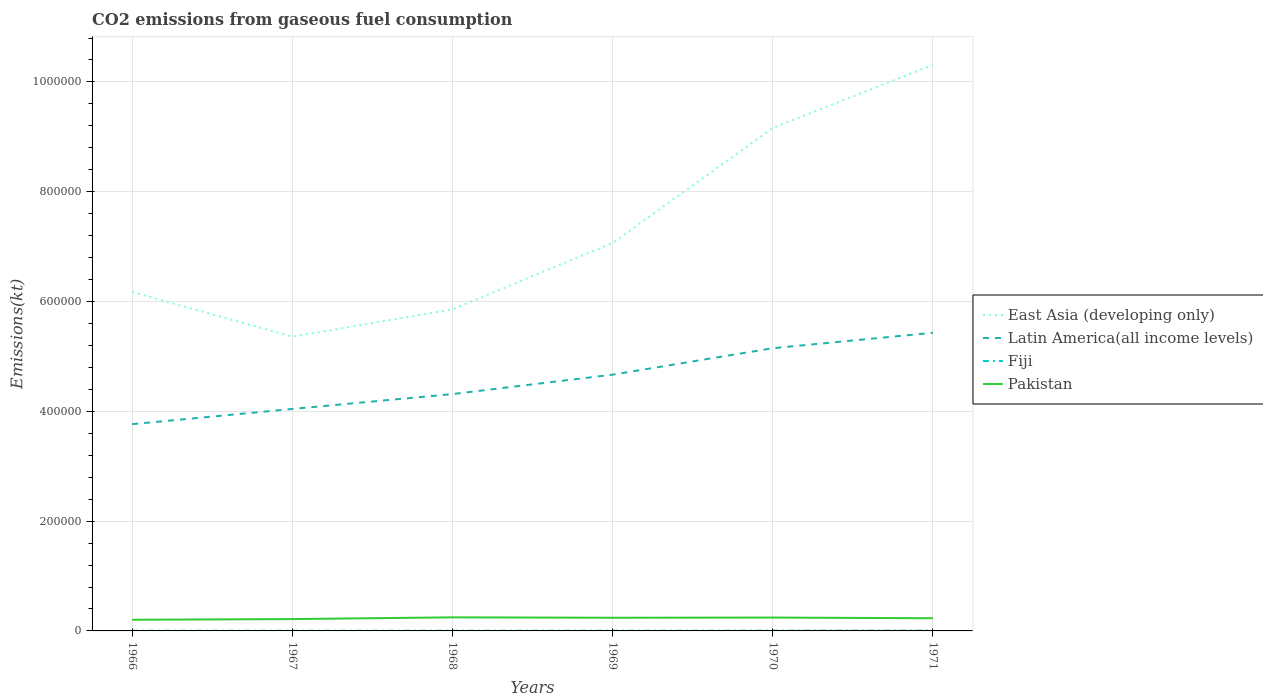Is the number of lines equal to the number of legend labels?
Your response must be concise. Yes. Across all years, what is the maximum amount of CO2 emitted in Latin America(all income levels)?
Provide a succinct answer. 3.77e+05. In which year was the amount of CO2 emitted in East Asia (developing only) maximum?
Offer a very short reply. 1967. What is the total amount of CO2 emitted in Latin America(all income levels) in the graph?
Your response must be concise. -7.63e+04. What is the difference between the highest and the second highest amount of CO2 emitted in East Asia (developing only)?
Your response must be concise. 4.95e+05. How many lines are there?
Make the answer very short. 4. What is the difference between two consecutive major ticks on the Y-axis?
Your answer should be compact. 2.00e+05. Does the graph contain any zero values?
Make the answer very short. No. Where does the legend appear in the graph?
Provide a succinct answer. Center right. How many legend labels are there?
Make the answer very short. 4. What is the title of the graph?
Make the answer very short. CO2 emissions from gaseous fuel consumption. Does "Vanuatu" appear as one of the legend labels in the graph?
Provide a short and direct response. No. What is the label or title of the X-axis?
Give a very brief answer. Years. What is the label or title of the Y-axis?
Provide a short and direct response. Emissions(kt). What is the Emissions(kt) of East Asia (developing only) in 1966?
Your answer should be very brief. 6.17e+05. What is the Emissions(kt) in Latin America(all income levels) in 1966?
Ensure brevity in your answer.  3.77e+05. What is the Emissions(kt) of Fiji in 1966?
Your answer should be compact. 322.7. What is the Emissions(kt) in Pakistan in 1966?
Your response must be concise. 2.03e+04. What is the Emissions(kt) in East Asia (developing only) in 1967?
Provide a short and direct response. 5.36e+05. What is the Emissions(kt) of Latin America(all income levels) in 1967?
Make the answer very short. 4.04e+05. What is the Emissions(kt) of Fiji in 1967?
Provide a short and direct response. 355.7. What is the Emissions(kt) in Pakistan in 1967?
Make the answer very short. 2.16e+04. What is the Emissions(kt) of East Asia (developing only) in 1968?
Make the answer very short. 5.86e+05. What is the Emissions(kt) in Latin America(all income levels) in 1968?
Your answer should be very brief. 4.31e+05. What is the Emissions(kt) in Fiji in 1968?
Your response must be concise. 396.04. What is the Emissions(kt) of Pakistan in 1968?
Give a very brief answer. 2.47e+04. What is the Emissions(kt) of East Asia (developing only) in 1969?
Your answer should be compact. 7.07e+05. What is the Emissions(kt) in Latin America(all income levels) in 1969?
Offer a very short reply. 4.67e+05. What is the Emissions(kt) of Fiji in 1969?
Make the answer very short. 432.71. What is the Emissions(kt) of Pakistan in 1969?
Your response must be concise. 2.40e+04. What is the Emissions(kt) of East Asia (developing only) in 1970?
Keep it short and to the point. 9.16e+05. What is the Emissions(kt) in Latin America(all income levels) in 1970?
Provide a short and direct response. 5.15e+05. What is the Emissions(kt) of Fiji in 1970?
Offer a terse response. 520.71. What is the Emissions(kt) of Pakistan in 1970?
Give a very brief answer. 2.43e+04. What is the Emissions(kt) of East Asia (developing only) in 1971?
Keep it short and to the point. 1.03e+06. What is the Emissions(kt) of Latin America(all income levels) in 1971?
Offer a terse response. 5.43e+05. What is the Emissions(kt) of Fiji in 1971?
Keep it short and to the point. 550.05. What is the Emissions(kt) of Pakistan in 1971?
Your answer should be compact. 2.31e+04. Across all years, what is the maximum Emissions(kt) in East Asia (developing only)?
Give a very brief answer. 1.03e+06. Across all years, what is the maximum Emissions(kt) of Latin America(all income levels)?
Keep it short and to the point. 5.43e+05. Across all years, what is the maximum Emissions(kt) of Fiji?
Your answer should be compact. 550.05. Across all years, what is the maximum Emissions(kt) of Pakistan?
Your response must be concise. 2.47e+04. Across all years, what is the minimum Emissions(kt) of East Asia (developing only)?
Give a very brief answer. 5.36e+05. Across all years, what is the minimum Emissions(kt) in Latin America(all income levels)?
Your answer should be very brief. 3.77e+05. Across all years, what is the minimum Emissions(kt) of Fiji?
Your answer should be compact. 322.7. Across all years, what is the minimum Emissions(kt) in Pakistan?
Your answer should be very brief. 2.03e+04. What is the total Emissions(kt) in East Asia (developing only) in the graph?
Provide a short and direct response. 4.39e+06. What is the total Emissions(kt) in Latin America(all income levels) in the graph?
Your response must be concise. 2.74e+06. What is the total Emissions(kt) of Fiji in the graph?
Your response must be concise. 2577.9. What is the total Emissions(kt) of Pakistan in the graph?
Offer a very short reply. 1.38e+05. What is the difference between the Emissions(kt) of East Asia (developing only) in 1966 and that in 1967?
Ensure brevity in your answer.  8.12e+04. What is the difference between the Emissions(kt) of Latin America(all income levels) in 1966 and that in 1967?
Your answer should be compact. -2.77e+04. What is the difference between the Emissions(kt) in Fiji in 1966 and that in 1967?
Your answer should be compact. -33. What is the difference between the Emissions(kt) of Pakistan in 1966 and that in 1967?
Keep it short and to the point. -1246.78. What is the difference between the Emissions(kt) in East Asia (developing only) in 1966 and that in 1968?
Ensure brevity in your answer.  3.16e+04. What is the difference between the Emissions(kt) in Latin America(all income levels) in 1966 and that in 1968?
Offer a very short reply. -5.48e+04. What is the difference between the Emissions(kt) of Fiji in 1966 and that in 1968?
Keep it short and to the point. -73.34. What is the difference between the Emissions(kt) in Pakistan in 1966 and that in 1968?
Your response must be concise. -4411.4. What is the difference between the Emissions(kt) in East Asia (developing only) in 1966 and that in 1969?
Your answer should be compact. -8.95e+04. What is the difference between the Emissions(kt) of Latin America(all income levels) in 1966 and that in 1969?
Your answer should be very brief. -9.02e+04. What is the difference between the Emissions(kt) in Fiji in 1966 and that in 1969?
Keep it short and to the point. -110.01. What is the difference between the Emissions(kt) in Pakistan in 1966 and that in 1969?
Offer a terse response. -3667. What is the difference between the Emissions(kt) in East Asia (developing only) in 1966 and that in 1970?
Offer a very short reply. -2.99e+05. What is the difference between the Emissions(kt) in Latin America(all income levels) in 1966 and that in 1970?
Make the answer very short. -1.38e+05. What is the difference between the Emissions(kt) of Fiji in 1966 and that in 1970?
Give a very brief answer. -198.02. What is the difference between the Emissions(kt) in Pakistan in 1966 and that in 1970?
Ensure brevity in your answer.  -4011.7. What is the difference between the Emissions(kt) of East Asia (developing only) in 1966 and that in 1971?
Offer a terse response. -4.14e+05. What is the difference between the Emissions(kt) in Latin America(all income levels) in 1966 and that in 1971?
Your response must be concise. -1.66e+05. What is the difference between the Emissions(kt) in Fiji in 1966 and that in 1971?
Offer a terse response. -227.35. What is the difference between the Emissions(kt) of Pakistan in 1966 and that in 1971?
Keep it short and to the point. -2750.25. What is the difference between the Emissions(kt) of East Asia (developing only) in 1967 and that in 1968?
Your answer should be very brief. -4.96e+04. What is the difference between the Emissions(kt) of Latin America(all income levels) in 1967 and that in 1968?
Keep it short and to the point. -2.71e+04. What is the difference between the Emissions(kt) in Fiji in 1967 and that in 1968?
Provide a short and direct response. -40.34. What is the difference between the Emissions(kt) of Pakistan in 1967 and that in 1968?
Provide a succinct answer. -3164.62. What is the difference between the Emissions(kt) of East Asia (developing only) in 1967 and that in 1969?
Provide a succinct answer. -1.71e+05. What is the difference between the Emissions(kt) in Latin America(all income levels) in 1967 and that in 1969?
Your answer should be compact. -6.25e+04. What is the difference between the Emissions(kt) of Fiji in 1967 and that in 1969?
Give a very brief answer. -77.01. What is the difference between the Emissions(kt) of Pakistan in 1967 and that in 1969?
Offer a very short reply. -2420.22. What is the difference between the Emissions(kt) in East Asia (developing only) in 1967 and that in 1970?
Ensure brevity in your answer.  -3.80e+05. What is the difference between the Emissions(kt) in Latin America(all income levels) in 1967 and that in 1970?
Ensure brevity in your answer.  -1.11e+05. What is the difference between the Emissions(kt) in Fiji in 1967 and that in 1970?
Your answer should be very brief. -165.01. What is the difference between the Emissions(kt) in Pakistan in 1967 and that in 1970?
Provide a short and direct response. -2764.92. What is the difference between the Emissions(kt) of East Asia (developing only) in 1967 and that in 1971?
Provide a succinct answer. -4.95e+05. What is the difference between the Emissions(kt) of Latin America(all income levels) in 1967 and that in 1971?
Offer a very short reply. -1.39e+05. What is the difference between the Emissions(kt) of Fiji in 1967 and that in 1971?
Your response must be concise. -194.35. What is the difference between the Emissions(kt) of Pakistan in 1967 and that in 1971?
Your response must be concise. -1503.47. What is the difference between the Emissions(kt) in East Asia (developing only) in 1968 and that in 1969?
Your answer should be compact. -1.21e+05. What is the difference between the Emissions(kt) of Latin America(all income levels) in 1968 and that in 1969?
Keep it short and to the point. -3.54e+04. What is the difference between the Emissions(kt) in Fiji in 1968 and that in 1969?
Provide a succinct answer. -36.67. What is the difference between the Emissions(kt) in Pakistan in 1968 and that in 1969?
Your response must be concise. 744.4. What is the difference between the Emissions(kt) in East Asia (developing only) in 1968 and that in 1970?
Your response must be concise. -3.30e+05. What is the difference between the Emissions(kt) of Latin America(all income levels) in 1968 and that in 1970?
Your answer should be compact. -8.36e+04. What is the difference between the Emissions(kt) in Fiji in 1968 and that in 1970?
Make the answer very short. -124.68. What is the difference between the Emissions(kt) in Pakistan in 1968 and that in 1970?
Offer a very short reply. 399.7. What is the difference between the Emissions(kt) of East Asia (developing only) in 1968 and that in 1971?
Your response must be concise. -4.45e+05. What is the difference between the Emissions(kt) of Latin America(all income levels) in 1968 and that in 1971?
Offer a very short reply. -1.12e+05. What is the difference between the Emissions(kt) of Fiji in 1968 and that in 1971?
Offer a terse response. -154.01. What is the difference between the Emissions(kt) of Pakistan in 1968 and that in 1971?
Provide a short and direct response. 1661.15. What is the difference between the Emissions(kt) of East Asia (developing only) in 1969 and that in 1970?
Your response must be concise. -2.09e+05. What is the difference between the Emissions(kt) in Latin America(all income levels) in 1969 and that in 1970?
Provide a short and direct response. -4.82e+04. What is the difference between the Emissions(kt) in Fiji in 1969 and that in 1970?
Provide a succinct answer. -88.01. What is the difference between the Emissions(kt) of Pakistan in 1969 and that in 1970?
Your answer should be compact. -344.7. What is the difference between the Emissions(kt) of East Asia (developing only) in 1969 and that in 1971?
Offer a very short reply. -3.24e+05. What is the difference between the Emissions(kt) of Latin America(all income levels) in 1969 and that in 1971?
Your answer should be very brief. -7.63e+04. What is the difference between the Emissions(kt) in Fiji in 1969 and that in 1971?
Provide a succinct answer. -117.34. What is the difference between the Emissions(kt) of Pakistan in 1969 and that in 1971?
Your answer should be very brief. 916.75. What is the difference between the Emissions(kt) of East Asia (developing only) in 1970 and that in 1971?
Offer a very short reply. -1.15e+05. What is the difference between the Emissions(kt) of Latin America(all income levels) in 1970 and that in 1971?
Ensure brevity in your answer.  -2.81e+04. What is the difference between the Emissions(kt) in Fiji in 1970 and that in 1971?
Your answer should be compact. -29.34. What is the difference between the Emissions(kt) of Pakistan in 1970 and that in 1971?
Your answer should be compact. 1261.45. What is the difference between the Emissions(kt) in East Asia (developing only) in 1966 and the Emissions(kt) in Latin America(all income levels) in 1967?
Ensure brevity in your answer.  2.13e+05. What is the difference between the Emissions(kt) in East Asia (developing only) in 1966 and the Emissions(kt) in Fiji in 1967?
Give a very brief answer. 6.17e+05. What is the difference between the Emissions(kt) of East Asia (developing only) in 1966 and the Emissions(kt) of Pakistan in 1967?
Offer a very short reply. 5.96e+05. What is the difference between the Emissions(kt) in Latin America(all income levels) in 1966 and the Emissions(kt) in Fiji in 1967?
Offer a very short reply. 3.76e+05. What is the difference between the Emissions(kt) in Latin America(all income levels) in 1966 and the Emissions(kt) in Pakistan in 1967?
Provide a succinct answer. 3.55e+05. What is the difference between the Emissions(kt) of Fiji in 1966 and the Emissions(kt) of Pakistan in 1967?
Provide a succinct answer. -2.13e+04. What is the difference between the Emissions(kt) in East Asia (developing only) in 1966 and the Emissions(kt) in Latin America(all income levels) in 1968?
Provide a succinct answer. 1.86e+05. What is the difference between the Emissions(kt) of East Asia (developing only) in 1966 and the Emissions(kt) of Fiji in 1968?
Provide a succinct answer. 6.17e+05. What is the difference between the Emissions(kt) in East Asia (developing only) in 1966 and the Emissions(kt) in Pakistan in 1968?
Ensure brevity in your answer.  5.93e+05. What is the difference between the Emissions(kt) in Latin America(all income levels) in 1966 and the Emissions(kt) in Fiji in 1968?
Your answer should be compact. 3.76e+05. What is the difference between the Emissions(kt) of Latin America(all income levels) in 1966 and the Emissions(kt) of Pakistan in 1968?
Offer a very short reply. 3.52e+05. What is the difference between the Emissions(kt) in Fiji in 1966 and the Emissions(kt) in Pakistan in 1968?
Offer a terse response. -2.44e+04. What is the difference between the Emissions(kt) in East Asia (developing only) in 1966 and the Emissions(kt) in Latin America(all income levels) in 1969?
Provide a short and direct response. 1.50e+05. What is the difference between the Emissions(kt) in East Asia (developing only) in 1966 and the Emissions(kt) in Fiji in 1969?
Your answer should be very brief. 6.17e+05. What is the difference between the Emissions(kt) in East Asia (developing only) in 1966 and the Emissions(kt) in Pakistan in 1969?
Give a very brief answer. 5.93e+05. What is the difference between the Emissions(kt) of Latin America(all income levels) in 1966 and the Emissions(kt) of Fiji in 1969?
Offer a very short reply. 3.76e+05. What is the difference between the Emissions(kt) of Latin America(all income levels) in 1966 and the Emissions(kt) of Pakistan in 1969?
Your response must be concise. 3.53e+05. What is the difference between the Emissions(kt) of Fiji in 1966 and the Emissions(kt) of Pakistan in 1969?
Offer a very short reply. -2.37e+04. What is the difference between the Emissions(kt) in East Asia (developing only) in 1966 and the Emissions(kt) in Latin America(all income levels) in 1970?
Ensure brevity in your answer.  1.02e+05. What is the difference between the Emissions(kt) in East Asia (developing only) in 1966 and the Emissions(kt) in Fiji in 1970?
Keep it short and to the point. 6.17e+05. What is the difference between the Emissions(kt) of East Asia (developing only) in 1966 and the Emissions(kt) of Pakistan in 1970?
Provide a succinct answer. 5.93e+05. What is the difference between the Emissions(kt) in Latin America(all income levels) in 1966 and the Emissions(kt) in Fiji in 1970?
Keep it short and to the point. 3.76e+05. What is the difference between the Emissions(kt) of Latin America(all income levels) in 1966 and the Emissions(kt) of Pakistan in 1970?
Provide a succinct answer. 3.52e+05. What is the difference between the Emissions(kt) in Fiji in 1966 and the Emissions(kt) in Pakistan in 1970?
Keep it short and to the point. -2.40e+04. What is the difference between the Emissions(kt) in East Asia (developing only) in 1966 and the Emissions(kt) in Latin America(all income levels) in 1971?
Provide a succinct answer. 7.42e+04. What is the difference between the Emissions(kt) in East Asia (developing only) in 1966 and the Emissions(kt) in Fiji in 1971?
Provide a succinct answer. 6.17e+05. What is the difference between the Emissions(kt) of East Asia (developing only) in 1966 and the Emissions(kt) of Pakistan in 1971?
Offer a terse response. 5.94e+05. What is the difference between the Emissions(kt) in Latin America(all income levels) in 1966 and the Emissions(kt) in Fiji in 1971?
Keep it short and to the point. 3.76e+05. What is the difference between the Emissions(kt) of Latin America(all income levels) in 1966 and the Emissions(kt) of Pakistan in 1971?
Provide a short and direct response. 3.54e+05. What is the difference between the Emissions(kt) in Fiji in 1966 and the Emissions(kt) in Pakistan in 1971?
Your answer should be very brief. -2.28e+04. What is the difference between the Emissions(kt) in East Asia (developing only) in 1967 and the Emissions(kt) in Latin America(all income levels) in 1968?
Your answer should be very brief. 1.05e+05. What is the difference between the Emissions(kt) of East Asia (developing only) in 1967 and the Emissions(kt) of Fiji in 1968?
Offer a very short reply. 5.36e+05. What is the difference between the Emissions(kt) in East Asia (developing only) in 1967 and the Emissions(kt) in Pakistan in 1968?
Make the answer very short. 5.11e+05. What is the difference between the Emissions(kt) of Latin America(all income levels) in 1967 and the Emissions(kt) of Fiji in 1968?
Provide a succinct answer. 4.04e+05. What is the difference between the Emissions(kt) of Latin America(all income levels) in 1967 and the Emissions(kt) of Pakistan in 1968?
Provide a succinct answer. 3.80e+05. What is the difference between the Emissions(kt) of Fiji in 1967 and the Emissions(kt) of Pakistan in 1968?
Make the answer very short. -2.44e+04. What is the difference between the Emissions(kt) in East Asia (developing only) in 1967 and the Emissions(kt) in Latin America(all income levels) in 1969?
Offer a terse response. 6.93e+04. What is the difference between the Emissions(kt) of East Asia (developing only) in 1967 and the Emissions(kt) of Fiji in 1969?
Give a very brief answer. 5.36e+05. What is the difference between the Emissions(kt) of East Asia (developing only) in 1967 and the Emissions(kt) of Pakistan in 1969?
Your response must be concise. 5.12e+05. What is the difference between the Emissions(kt) in Latin America(all income levels) in 1967 and the Emissions(kt) in Fiji in 1969?
Offer a terse response. 4.04e+05. What is the difference between the Emissions(kt) of Latin America(all income levels) in 1967 and the Emissions(kt) of Pakistan in 1969?
Keep it short and to the point. 3.80e+05. What is the difference between the Emissions(kt) in Fiji in 1967 and the Emissions(kt) in Pakistan in 1969?
Provide a short and direct response. -2.36e+04. What is the difference between the Emissions(kt) of East Asia (developing only) in 1967 and the Emissions(kt) of Latin America(all income levels) in 1970?
Give a very brief answer. 2.11e+04. What is the difference between the Emissions(kt) of East Asia (developing only) in 1967 and the Emissions(kt) of Fiji in 1970?
Ensure brevity in your answer.  5.36e+05. What is the difference between the Emissions(kt) of East Asia (developing only) in 1967 and the Emissions(kt) of Pakistan in 1970?
Offer a very short reply. 5.12e+05. What is the difference between the Emissions(kt) of Latin America(all income levels) in 1967 and the Emissions(kt) of Fiji in 1970?
Provide a succinct answer. 4.04e+05. What is the difference between the Emissions(kt) of Latin America(all income levels) in 1967 and the Emissions(kt) of Pakistan in 1970?
Offer a very short reply. 3.80e+05. What is the difference between the Emissions(kt) in Fiji in 1967 and the Emissions(kt) in Pakistan in 1970?
Ensure brevity in your answer.  -2.40e+04. What is the difference between the Emissions(kt) in East Asia (developing only) in 1967 and the Emissions(kt) in Latin America(all income levels) in 1971?
Keep it short and to the point. -7044.1. What is the difference between the Emissions(kt) of East Asia (developing only) in 1967 and the Emissions(kt) of Fiji in 1971?
Offer a terse response. 5.36e+05. What is the difference between the Emissions(kt) of East Asia (developing only) in 1967 and the Emissions(kt) of Pakistan in 1971?
Offer a terse response. 5.13e+05. What is the difference between the Emissions(kt) of Latin America(all income levels) in 1967 and the Emissions(kt) of Fiji in 1971?
Keep it short and to the point. 4.04e+05. What is the difference between the Emissions(kt) of Latin America(all income levels) in 1967 and the Emissions(kt) of Pakistan in 1971?
Give a very brief answer. 3.81e+05. What is the difference between the Emissions(kt) of Fiji in 1967 and the Emissions(kt) of Pakistan in 1971?
Your response must be concise. -2.27e+04. What is the difference between the Emissions(kt) of East Asia (developing only) in 1968 and the Emissions(kt) of Latin America(all income levels) in 1969?
Give a very brief answer. 1.19e+05. What is the difference between the Emissions(kt) in East Asia (developing only) in 1968 and the Emissions(kt) in Fiji in 1969?
Offer a very short reply. 5.85e+05. What is the difference between the Emissions(kt) of East Asia (developing only) in 1968 and the Emissions(kt) of Pakistan in 1969?
Give a very brief answer. 5.62e+05. What is the difference between the Emissions(kt) in Latin America(all income levels) in 1968 and the Emissions(kt) in Fiji in 1969?
Make the answer very short. 4.31e+05. What is the difference between the Emissions(kt) in Latin America(all income levels) in 1968 and the Emissions(kt) in Pakistan in 1969?
Keep it short and to the point. 4.07e+05. What is the difference between the Emissions(kt) in Fiji in 1968 and the Emissions(kt) in Pakistan in 1969?
Give a very brief answer. -2.36e+04. What is the difference between the Emissions(kt) in East Asia (developing only) in 1968 and the Emissions(kt) in Latin America(all income levels) in 1970?
Provide a succinct answer. 7.06e+04. What is the difference between the Emissions(kt) in East Asia (developing only) in 1968 and the Emissions(kt) in Fiji in 1970?
Give a very brief answer. 5.85e+05. What is the difference between the Emissions(kt) in East Asia (developing only) in 1968 and the Emissions(kt) in Pakistan in 1970?
Offer a very short reply. 5.61e+05. What is the difference between the Emissions(kt) in Latin America(all income levels) in 1968 and the Emissions(kt) in Fiji in 1970?
Keep it short and to the point. 4.31e+05. What is the difference between the Emissions(kt) in Latin America(all income levels) in 1968 and the Emissions(kt) in Pakistan in 1970?
Your answer should be very brief. 4.07e+05. What is the difference between the Emissions(kt) in Fiji in 1968 and the Emissions(kt) in Pakistan in 1970?
Keep it short and to the point. -2.39e+04. What is the difference between the Emissions(kt) in East Asia (developing only) in 1968 and the Emissions(kt) in Latin America(all income levels) in 1971?
Your answer should be compact. 4.25e+04. What is the difference between the Emissions(kt) in East Asia (developing only) in 1968 and the Emissions(kt) in Fiji in 1971?
Offer a very short reply. 5.85e+05. What is the difference between the Emissions(kt) of East Asia (developing only) in 1968 and the Emissions(kt) of Pakistan in 1971?
Make the answer very short. 5.63e+05. What is the difference between the Emissions(kt) in Latin America(all income levels) in 1968 and the Emissions(kt) in Fiji in 1971?
Your answer should be very brief. 4.31e+05. What is the difference between the Emissions(kt) of Latin America(all income levels) in 1968 and the Emissions(kt) of Pakistan in 1971?
Your response must be concise. 4.08e+05. What is the difference between the Emissions(kt) of Fiji in 1968 and the Emissions(kt) of Pakistan in 1971?
Give a very brief answer. -2.27e+04. What is the difference between the Emissions(kt) of East Asia (developing only) in 1969 and the Emissions(kt) of Latin America(all income levels) in 1970?
Provide a succinct answer. 1.92e+05. What is the difference between the Emissions(kt) of East Asia (developing only) in 1969 and the Emissions(kt) of Fiji in 1970?
Offer a terse response. 7.06e+05. What is the difference between the Emissions(kt) of East Asia (developing only) in 1969 and the Emissions(kt) of Pakistan in 1970?
Give a very brief answer. 6.82e+05. What is the difference between the Emissions(kt) of Latin America(all income levels) in 1969 and the Emissions(kt) of Fiji in 1970?
Your response must be concise. 4.66e+05. What is the difference between the Emissions(kt) of Latin America(all income levels) in 1969 and the Emissions(kt) of Pakistan in 1970?
Provide a succinct answer. 4.42e+05. What is the difference between the Emissions(kt) in Fiji in 1969 and the Emissions(kt) in Pakistan in 1970?
Provide a succinct answer. -2.39e+04. What is the difference between the Emissions(kt) in East Asia (developing only) in 1969 and the Emissions(kt) in Latin America(all income levels) in 1971?
Give a very brief answer. 1.64e+05. What is the difference between the Emissions(kt) in East Asia (developing only) in 1969 and the Emissions(kt) in Fiji in 1971?
Offer a terse response. 7.06e+05. What is the difference between the Emissions(kt) of East Asia (developing only) in 1969 and the Emissions(kt) of Pakistan in 1971?
Make the answer very short. 6.84e+05. What is the difference between the Emissions(kt) of Latin America(all income levels) in 1969 and the Emissions(kt) of Fiji in 1971?
Your answer should be compact. 4.66e+05. What is the difference between the Emissions(kt) in Latin America(all income levels) in 1969 and the Emissions(kt) in Pakistan in 1971?
Provide a succinct answer. 4.44e+05. What is the difference between the Emissions(kt) of Fiji in 1969 and the Emissions(kt) of Pakistan in 1971?
Your answer should be very brief. -2.26e+04. What is the difference between the Emissions(kt) in East Asia (developing only) in 1970 and the Emissions(kt) in Latin America(all income levels) in 1971?
Provide a succinct answer. 3.73e+05. What is the difference between the Emissions(kt) of East Asia (developing only) in 1970 and the Emissions(kt) of Fiji in 1971?
Provide a short and direct response. 9.16e+05. What is the difference between the Emissions(kt) of East Asia (developing only) in 1970 and the Emissions(kt) of Pakistan in 1971?
Keep it short and to the point. 8.93e+05. What is the difference between the Emissions(kt) of Latin America(all income levels) in 1970 and the Emissions(kt) of Fiji in 1971?
Offer a terse response. 5.14e+05. What is the difference between the Emissions(kt) in Latin America(all income levels) in 1970 and the Emissions(kt) in Pakistan in 1971?
Make the answer very short. 4.92e+05. What is the difference between the Emissions(kt) in Fiji in 1970 and the Emissions(kt) in Pakistan in 1971?
Make the answer very short. -2.26e+04. What is the average Emissions(kt) of East Asia (developing only) per year?
Keep it short and to the point. 7.32e+05. What is the average Emissions(kt) of Latin America(all income levels) per year?
Provide a succinct answer. 4.56e+05. What is the average Emissions(kt) in Fiji per year?
Make the answer very short. 429.65. What is the average Emissions(kt) of Pakistan per year?
Your answer should be compact. 2.30e+04. In the year 1966, what is the difference between the Emissions(kt) in East Asia (developing only) and Emissions(kt) in Latin America(all income levels)?
Ensure brevity in your answer.  2.41e+05. In the year 1966, what is the difference between the Emissions(kt) in East Asia (developing only) and Emissions(kt) in Fiji?
Offer a very short reply. 6.17e+05. In the year 1966, what is the difference between the Emissions(kt) in East Asia (developing only) and Emissions(kt) in Pakistan?
Offer a very short reply. 5.97e+05. In the year 1966, what is the difference between the Emissions(kt) of Latin America(all income levels) and Emissions(kt) of Fiji?
Provide a succinct answer. 3.76e+05. In the year 1966, what is the difference between the Emissions(kt) in Latin America(all income levels) and Emissions(kt) in Pakistan?
Offer a terse response. 3.56e+05. In the year 1966, what is the difference between the Emissions(kt) in Fiji and Emissions(kt) in Pakistan?
Your answer should be compact. -2.00e+04. In the year 1967, what is the difference between the Emissions(kt) in East Asia (developing only) and Emissions(kt) in Latin America(all income levels)?
Ensure brevity in your answer.  1.32e+05. In the year 1967, what is the difference between the Emissions(kt) in East Asia (developing only) and Emissions(kt) in Fiji?
Ensure brevity in your answer.  5.36e+05. In the year 1967, what is the difference between the Emissions(kt) of East Asia (developing only) and Emissions(kt) of Pakistan?
Your answer should be compact. 5.14e+05. In the year 1967, what is the difference between the Emissions(kt) of Latin America(all income levels) and Emissions(kt) of Fiji?
Your response must be concise. 4.04e+05. In the year 1967, what is the difference between the Emissions(kt) of Latin America(all income levels) and Emissions(kt) of Pakistan?
Provide a succinct answer. 3.83e+05. In the year 1967, what is the difference between the Emissions(kt) in Fiji and Emissions(kt) in Pakistan?
Provide a short and direct response. -2.12e+04. In the year 1968, what is the difference between the Emissions(kt) in East Asia (developing only) and Emissions(kt) in Latin America(all income levels)?
Ensure brevity in your answer.  1.54e+05. In the year 1968, what is the difference between the Emissions(kt) in East Asia (developing only) and Emissions(kt) in Fiji?
Your answer should be very brief. 5.85e+05. In the year 1968, what is the difference between the Emissions(kt) of East Asia (developing only) and Emissions(kt) of Pakistan?
Your answer should be very brief. 5.61e+05. In the year 1968, what is the difference between the Emissions(kt) of Latin America(all income levels) and Emissions(kt) of Fiji?
Your answer should be very brief. 4.31e+05. In the year 1968, what is the difference between the Emissions(kt) in Latin America(all income levels) and Emissions(kt) in Pakistan?
Provide a short and direct response. 4.07e+05. In the year 1968, what is the difference between the Emissions(kt) of Fiji and Emissions(kt) of Pakistan?
Provide a succinct answer. -2.43e+04. In the year 1969, what is the difference between the Emissions(kt) in East Asia (developing only) and Emissions(kt) in Latin America(all income levels)?
Provide a short and direct response. 2.40e+05. In the year 1969, what is the difference between the Emissions(kt) in East Asia (developing only) and Emissions(kt) in Fiji?
Give a very brief answer. 7.06e+05. In the year 1969, what is the difference between the Emissions(kt) in East Asia (developing only) and Emissions(kt) in Pakistan?
Offer a terse response. 6.83e+05. In the year 1969, what is the difference between the Emissions(kt) of Latin America(all income levels) and Emissions(kt) of Fiji?
Your response must be concise. 4.66e+05. In the year 1969, what is the difference between the Emissions(kt) of Latin America(all income levels) and Emissions(kt) of Pakistan?
Provide a succinct answer. 4.43e+05. In the year 1969, what is the difference between the Emissions(kt) in Fiji and Emissions(kt) in Pakistan?
Provide a short and direct response. -2.36e+04. In the year 1970, what is the difference between the Emissions(kt) in East Asia (developing only) and Emissions(kt) in Latin America(all income levels)?
Offer a terse response. 4.01e+05. In the year 1970, what is the difference between the Emissions(kt) of East Asia (developing only) and Emissions(kt) of Fiji?
Provide a succinct answer. 9.16e+05. In the year 1970, what is the difference between the Emissions(kt) in East Asia (developing only) and Emissions(kt) in Pakistan?
Give a very brief answer. 8.92e+05. In the year 1970, what is the difference between the Emissions(kt) of Latin America(all income levels) and Emissions(kt) of Fiji?
Offer a terse response. 5.14e+05. In the year 1970, what is the difference between the Emissions(kt) of Latin America(all income levels) and Emissions(kt) of Pakistan?
Keep it short and to the point. 4.91e+05. In the year 1970, what is the difference between the Emissions(kt) in Fiji and Emissions(kt) in Pakistan?
Make the answer very short. -2.38e+04. In the year 1971, what is the difference between the Emissions(kt) of East Asia (developing only) and Emissions(kt) of Latin America(all income levels)?
Provide a short and direct response. 4.88e+05. In the year 1971, what is the difference between the Emissions(kt) of East Asia (developing only) and Emissions(kt) of Fiji?
Your answer should be compact. 1.03e+06. In the year 1971, what is the difference between the Emissions(kt) of East Asia (developing only) and Emissions(kt) of Pakistan?
Offer a very short reply. 1.01e+06. In the year 1971, what is the difference between the Emissions(kt) of Latin America(all income levels) and Emissions(kt) of Fiji?
Offer a terse response. 5.43e+05. In the year 1971, what is the difference between the Emissions(kt) in Latin America(all income levels) and Emissions(kt) in Pakistan?
Ensure brevity in your answer.  5.20e+05. In the year 1971, what is the difference between the Emissions(kt) of Fiji and Emissions(kt) of Pakistan?
Your answer should be compact. -2.25e+04. What is the ratio of the Emissions(kt) in East Asia (developing only) in 1966 to that in 1967?
Give a very brief answer. 1.15. What is the ratio of the Emissions(kt) in Latin America(all income levels) in 1966 to that in 1967?
Your answer should be compact. 0.93. What is the ratio of the Emissions(kt) of Fiji in 1966 to that in 1967?
Your response must be concise. 0.91. What is the ratio of the Emissions(kt) of Pakistan in 1966 to that in 1967?
Keep it short and to the point. 0.94. What is the ratio of the Emissions(kt) of East Asia (developing only) in 1966 to that in 1968?
Keep it short and to the point. 1.05. What is the ratio of the Emissions(kt) in Latin America(all income levels) in 1966 to that in 1968?
Offer a very short reply. 0.87. What is the ratio of the Emissions(kt) in Fiji in 1966 to that in 1968?
Give a very brief answer. 0.81. What is the ratio of the Emissions(kt) of Pakistan in 1966 to that in 1968?
Offer a very short reply. 0.82. What is the ratio of the Emissions(kt) in East Asia (developing only) in 1966 to that in 1969?
Provide a succinct answer. 0.87. What is the ratio of the Emissions(kt) of Latin America(all income levels) in 1966 to that in 1969?
Give a very brief answer. 0.81. What is the ratio of the Emissions(kt) of Fiji in 1966 to that in 1969?
Your answer should be very brief. 0.75. What is the ratio of the Emissions(kt) in Pakistan in 1966 to that in 1969?
Ensure brevity in your answer.  0.85. What is the ratio of the Emissions(kt) of East Asia (developing only) in 1966 to that in 1970?
Offer a very short reply. 0.67. What is the ratio of the Emissions(kt) of Latin America(all income levels) in 1966 to that in 1970?
Provide a succinct answer. 0.73. What is the ratio of the Emissions(kt) of Fiji in 1966 to that in 1970?
Keep it short and to the point. 0.62. What is the ratio of the Emissions(kt) in Pakistan in 1966 to that in 1970?
Offer a very short reply. 0.84. What is the ratio of the Emissions(kt) in East Asia (developing only) in 1966 to that in 1971?
Offer a very short reply. 0.6. What is the ratio of the Emissions(kt) of Latin America(all income levels) in 1966 to that in 1971?
Give a very brief answer. 0.69. What is the ratio of the Emissions(kt) of Fiji in 1966 to that in 1971?
Your answer should be compact. 0.59. What is the ratio of the Emissions(kt) of Pakistan in 1966 to that in 1971?
Keep it short and to the point. 0.88. What is the ratio of the Emissions(kt) of East Asia (developing only) in 1967 to that in 1968?
Your response must be concise. 0.92. What is the ratio of the Emissions(kt) in Latin America(all income levels) in 1967 to that in 1968?
Make the answer very short. 0.94. What is the ratio of the Emissions(kt) in Fiji in 1967 to that in 1968?
Your response must be concise. 0.9. What is the ratio of the Emissions(kt) in Pakistan in 1967 to that in 1968?
Keep it short and to the point. 0.87. What is the ratio of the Emissions(kt) in East Asia (developing only) in 1967 to that in 1969?
Your answer should be very brief. 0.76. What is the ratio of the Emissions(kt) of Latin America(all income levels) in 1967 to that in 1969?
Your answer should be very brief. 0.87. What is the ratio of the Emissions(kt) in Fiji in 1967 to that in 1969?
Your response must be concise. 0.82. What is the ratio of the Emissions(kt) in Pakistan in 1967 to that in 1969?
Offer a very short reply. 0.9. What is the ratio of the Emissions(kt) in East Asia (developing only) in 1967 to that in 1970?
Give a very brief answer. 0.59. What is the ratio of the Emissions(kt) in Latin America(all income levels) in 1967 to that in 1970?
Offer a very short reply. 0.79. What is the ratio of the Emissions(kt) of Fiji in 1967 to that in 1970?
Your answer should be compact. 0.68. What is the ratio of the Emissions(kt) of Pakistan in 1967 to that in 1970?
Keep it short and to the point. 0.89. What is the ratio of the Emissions(kt) in East Asia (developing only) in 1967 to that in 1971?
Your answer should be very brief. 0.52. What is the ratio of the Emissions(kt) of Latin America(all income levels) in 1967 to that in 1971?
Offer a very short reply. 0.74. What is the ratio of the Emissions(kt) in Fiji in 1967 to that in 1971?
Ensure brevity in your answer.  0.65. What is the ratio of the Emissions(kt) of Pakistan in 1967 to that in 1971?
Your answer should be compact. 0.93. What is the ratio of the Emissions(kt) in East Asia (developing only) in 1968 to that in 1969?
Provide a succinct answer. 0.83. What is the ratio of the Emissions(kt) of Latin America(all income levels) in 1968 to that in 1969?
Your answer should be very brief. 0.92. What is the ratio of the Emissions(kt) in Fiji in 1968 to that in 1969?
Ensure brevity in your answer.  0.92. What is the ratio of the Emissions(kt) in Pakistan in 1968 to that in 1969?
Your answer should be very brief. 1.03. What is the ratio of the Emissions(kt) of East Asia (developing only) in 1968 to that in 1970?
Ensure brevity in your answer.  0.64. What is the ratio of the Emissions(kt) of Latin America(all income levels) in 1968 to that in 1970?
Offer a very short reply. 0.84. What is the ratio of the Emissions(kt) in Fiji in 1968 to that in 1970?
Provide a succinct answer. 0.76. What is the ratio of the Emissions(kt) of Pakistan in 1968 to that in 1970?
Provide a short and direct response. 1.02. What is the ratio of the Emissions(kt) of East Asia (developing only) in 1968 to that in 1971?
Give a very brief answer. 0.57. What is the ratio of the Emissions(kt) of Latin America(all income levels) in 1968 to that in 1971?
Provide a succinct answer. 0.79. What is the ratio of the Emissions(kt) in Fiji in 1968 to that in 1971?
Offer a terse response. 0.72. What is the ratio of the Emissions(kt) in Pakistan in 1968 to that in 1971?
Make the answer very short. 1.07. What is the ratio of the Emissions(kt) of East Asia (developing only) in 1969 to that in 1970?
Offer a very short reply. 0.77. What is the ratio of the Emissions(kt) of Latin America(all income levels) in 1969 to that in 1970?
Ensure brevity in your answer.  0.91. What is the ratio of the Emissions(kt) of Fiji in 1969 to that in 1970?
Provide a short and direct response. 0.83. What is the ratio of the Emissions(kt) of Pakistan in 1969 to that in 1970?
Provide a short and direct response. 0.99. What is the ratio of the Emissions(kt) of East Asia (developing only) in 1969 to that in 1971?
Your response must be concise. 0.69. What is the ratio of the Emissions(kt) in Latin America(all income levels) in 1969 to that in 1971?
Ensure brevity in your answer.  0.86. What is the ratio of the Emissions(kt) in Fiji in 1969 to that in 1971?
Your answer should be compact. 0.79. What is the ratio of the Emissions(kt) in Pakistan in 1969 to that in 1971?
Keep it short and to the point. 1.04. What is the ratio of the Emissions(kt) of East Asia (developing only) in 1970 to that in 1971?
Your response must be concise. 0.89. What is the ratio of the Emissions(kt) of Latin America(all income levels) in 1970 to that in 1971?
Offer a terse response. 0.95. What is the ratio of the Emissions(kt) of Fiji in 1970 to that in 1971?
Your answer should be very brief. 0.95. What is the ratio of the Emissions(kt) of Pakistan in 1970 to that in 1971?
Your answer should be very brief. 1.05. What is the difference between the highest and the second highest Emissions(kt) of East Asia (developing only)?
Your answer should be compact. 1.15e+05. What is the difference between the highest and the second highest Emissions(kt) of Latin America(all income levels)?
Give a very brief answer. 2.81e+04. What is the difference between the highest and the second highest Emissions(kt) of Fiji?
Offer a terse response. 29.34. What is the difference between the highest and the second highest Emissions(kt) in Pakistan?
Your answer should be compact. 399.7. What is the difference between the highest and the lowest Emissions(kt) in East Asia (developing only)?
Your response must be concise. 4.95e+05. What is the difference between the highest and the lowest Emissions(kt) of Latin America(all income levels)?
Make the answer very short. 1.66e+05. What is the difference between the highest and the lowest Emissions(kt) of Fiji?
Your answer should be compact. 227.35. What is the difference between the highest and the lowest Emissions(kt) in Pakistan?
Your answer should be compact. 4411.4. 